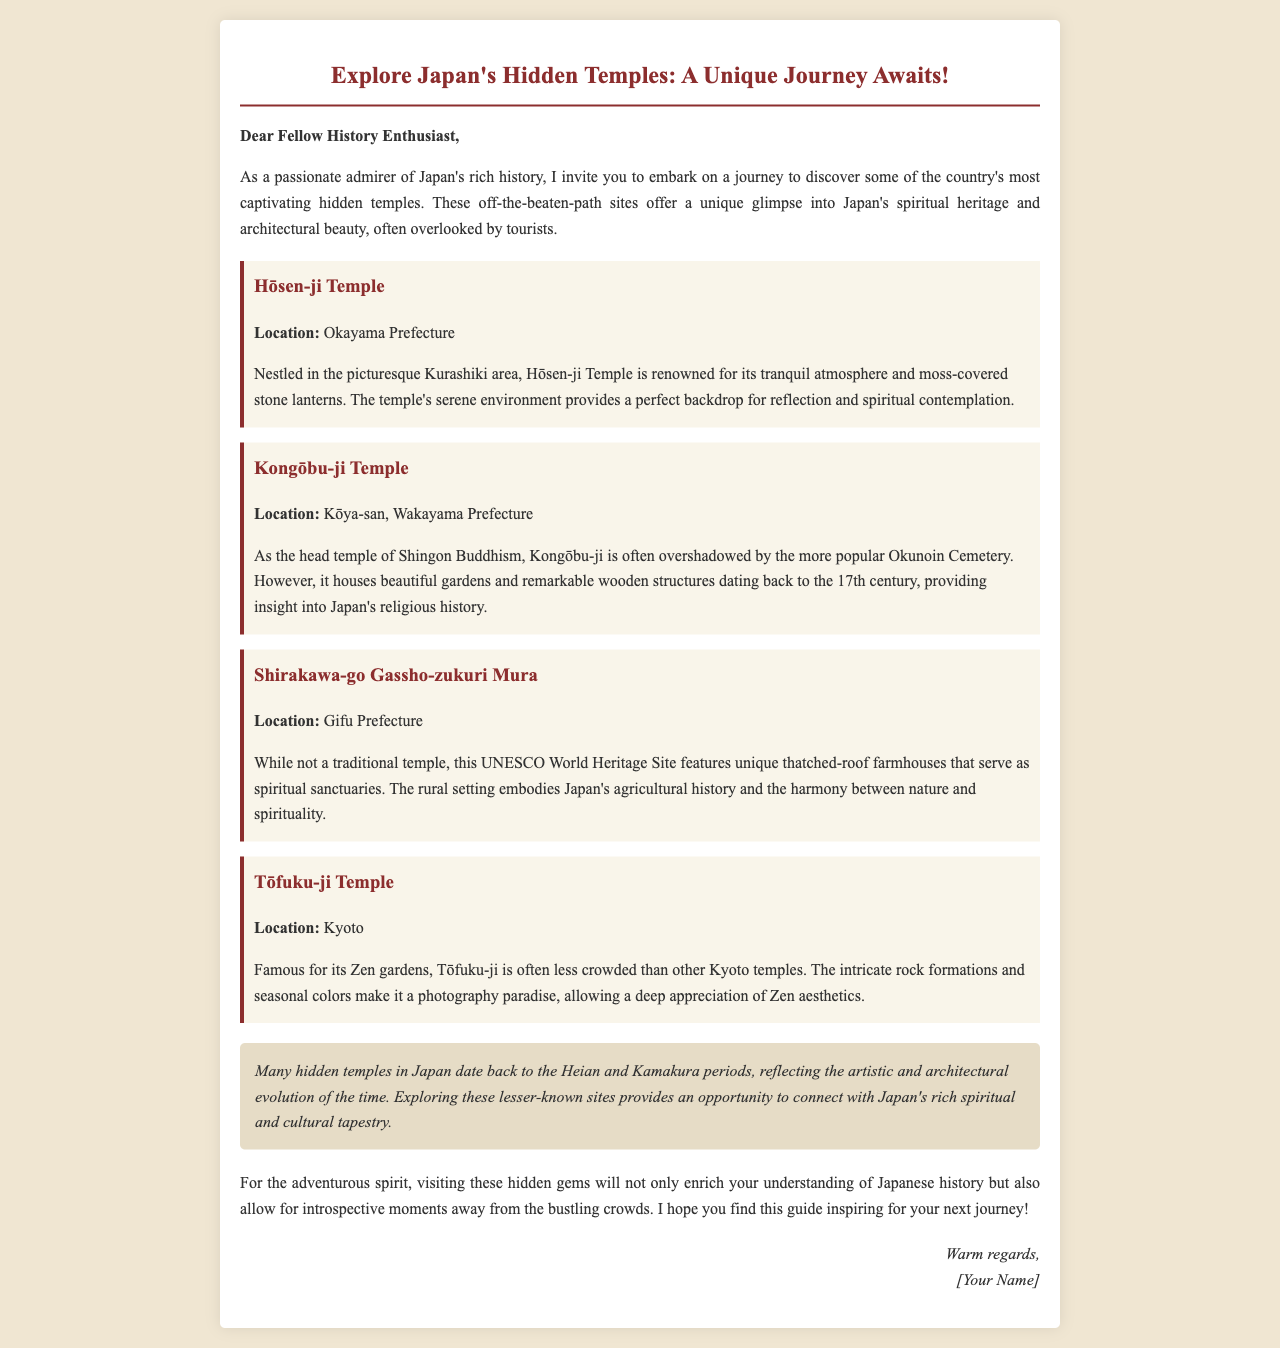What is the title of the document? The title is prominently displayed at the top of the document.
Answer: Explore Japan's Hidden Temples: A Unique Journey Awaits! Where is Hōsen-ji Temple located? The document provides the specific location of Hōsen-ji Temple.
Answer: Okayama Prefecture Which UNESCO World Heritage Site is mentioned in the document? The document specifies the UNESCO site among the discussed temples.
Answer: Shirakawa-go Gassho-zukuri Mura What period do many hidden temples in Japan date back to? The historical context provides information about the time period of the temples.
Answer: Heian and Kamakura periods What type of Buddhism is Kongōbu-ji Temple associated with? The document describes the religious affiliation of Kongōbu-ji Temple.
Answer: Shingon Buddhism How does the document describe the environment of Hōsen-ji Temple? The document includes a description of the atmosphere at Hōsen-ji Temple.
Answer: Tranquil atmosphere What aesthetic does Tōfuku-ji Temple emphasize? The text mentions a specific aspect of Tōfuku-ji Temple's appeal.
Answer: Zen aesthetics 